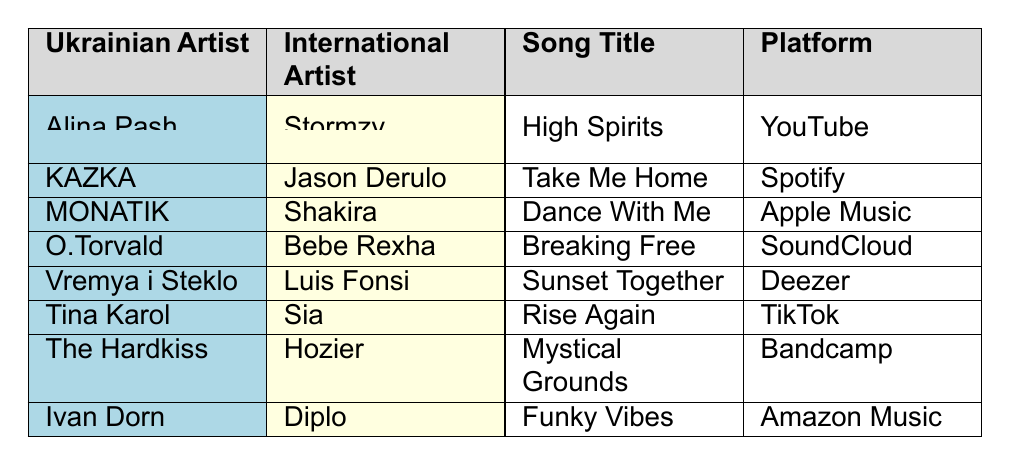What is the song title of Alina Pash's collaboration with Stormzy? The table lists Alina Pash as collaborating with Stormzy on the song titled "High Spirits."
Answer: High Spirits Which artist collaborated with Jason Derulo? Looking at the table, KAZKA is the Ukrainian artist who collaborated with Jason Derulo.
Answer: KAZKA How many songs listed have a release date in 2023? There are 8 songs listed in the table, all of which have a release date in 2023, as each entry displays a release date within that year.
Answer: 8 Which genre does the song "Rise Again" belong to? Referring to the table, the song "Rise Again" by Tina Karol is categorized under the Pop genre.
Answer: Pop Who are the international artists that collaborated with Ukrainian artists in the Rock genre? From the table, the only collaboration in the Rock genre is by O.Torvald with Bebe Rexha on the song "Breaking Free."
Answer: Bebe Rexha What is the platform for the song "Dance With Me"? The table indicates that the song "Dance With Me" by MONATIK featuring Shakira is available on Apple Music.
Answer: Apple Music Which Ukrainian artist has the most recent collaboration listed? The most recent collaboration listed is by O.Torvald on November 2 with Bebe Rexha, making O.Torvald the Ukrainian artist with the latest collaboration.
Answer: O.Torvald Is there a collaboration that features a song on TikTok? The table shows that Tina Karol's song "Rise Again" is indeed listed as being available on TikTok.
Answer: Yes How many collaborations fall under the Dance genre? The table lists one collaboration in the Dance genre, which is "Dance With Me" by MONATIK featuring Shakira.
Answer: 1 Which platform features the most collaborations based on this data? Analyzing the table, each platform features one song, suggesting no platform has more than one; hence, they are all equal.
Answer: All platforms have one 